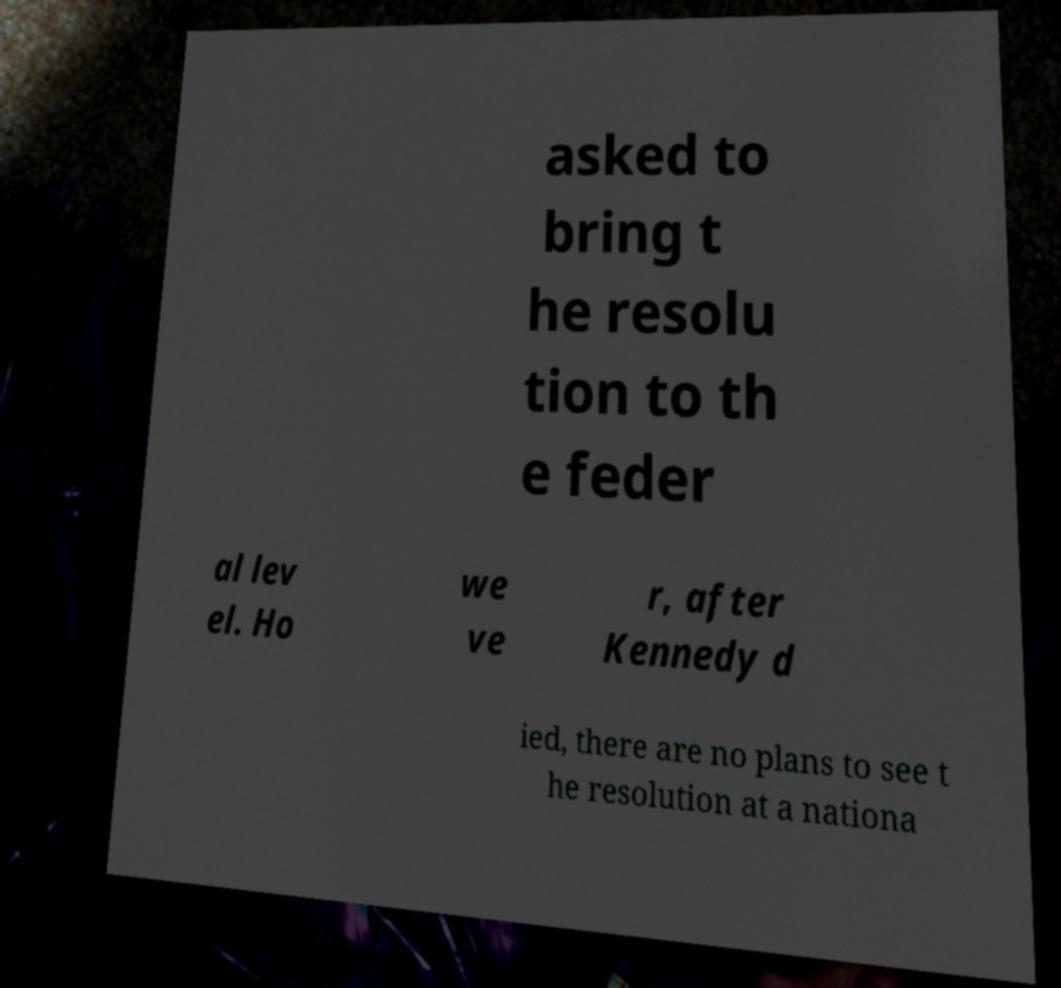I need the written content from this picture converted into text. Can you do that? asked to bring t he resolu tion to th e feder al lev el. Ho we ve r, after Kennedy d ied, there are no plans to see t he resolution at a nationa 